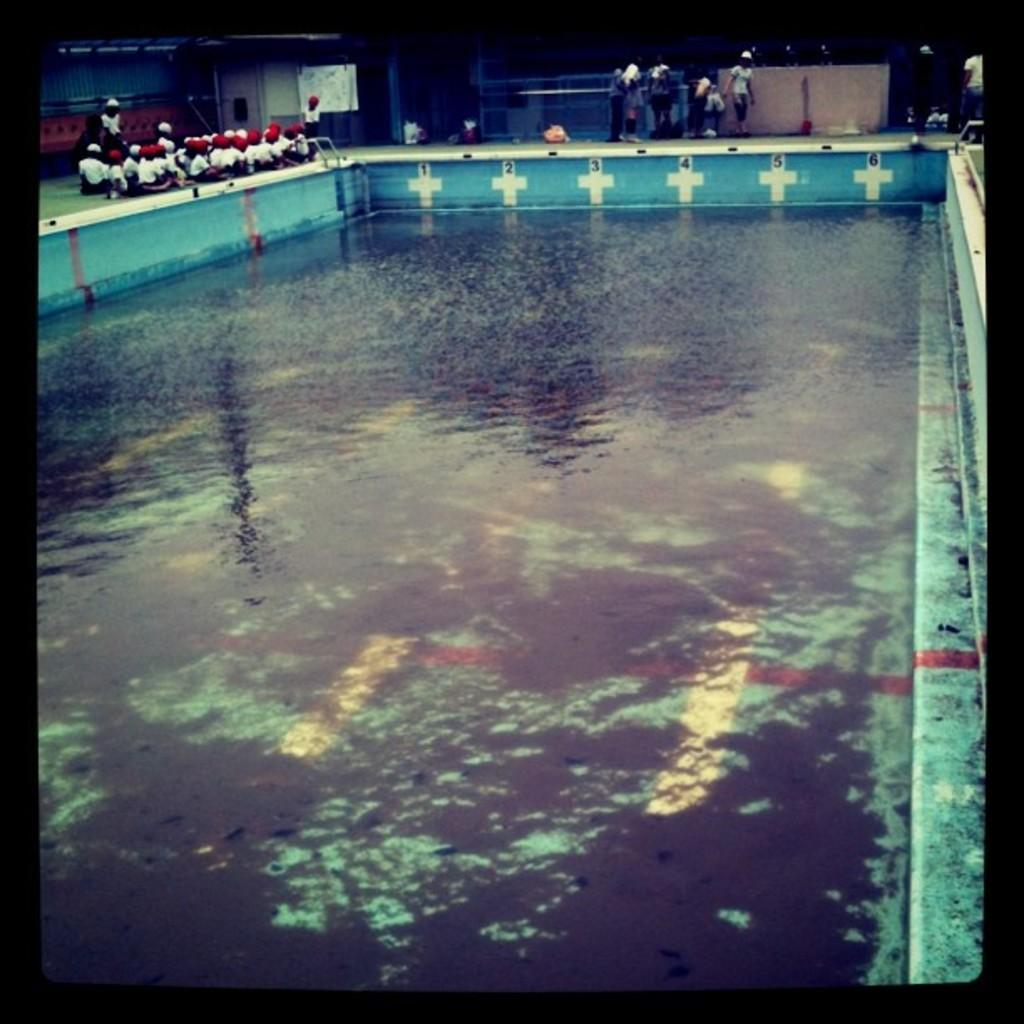What is located at the bottom of the picture? There is a swimming pool at the bottom of the picture. What can be seen in the background of the image? There are persons and a wall visible in the background of the image. Are there any artificial light sources in the background of the image? Yes, there are lights in the background of the image. What type of stone is being used to measure the depth of the swimming pool in the image? There is no stone or measuring device visible in the image, and the depth of the swimming pool is not mentioned in the provided facts. 